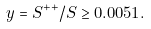Convert formula to latex. <formula><loc_0><loc_0><loc_500><loc_500>y = S ^ { + + } / S \geq 0 . 0 0 5 1 .</formula> 